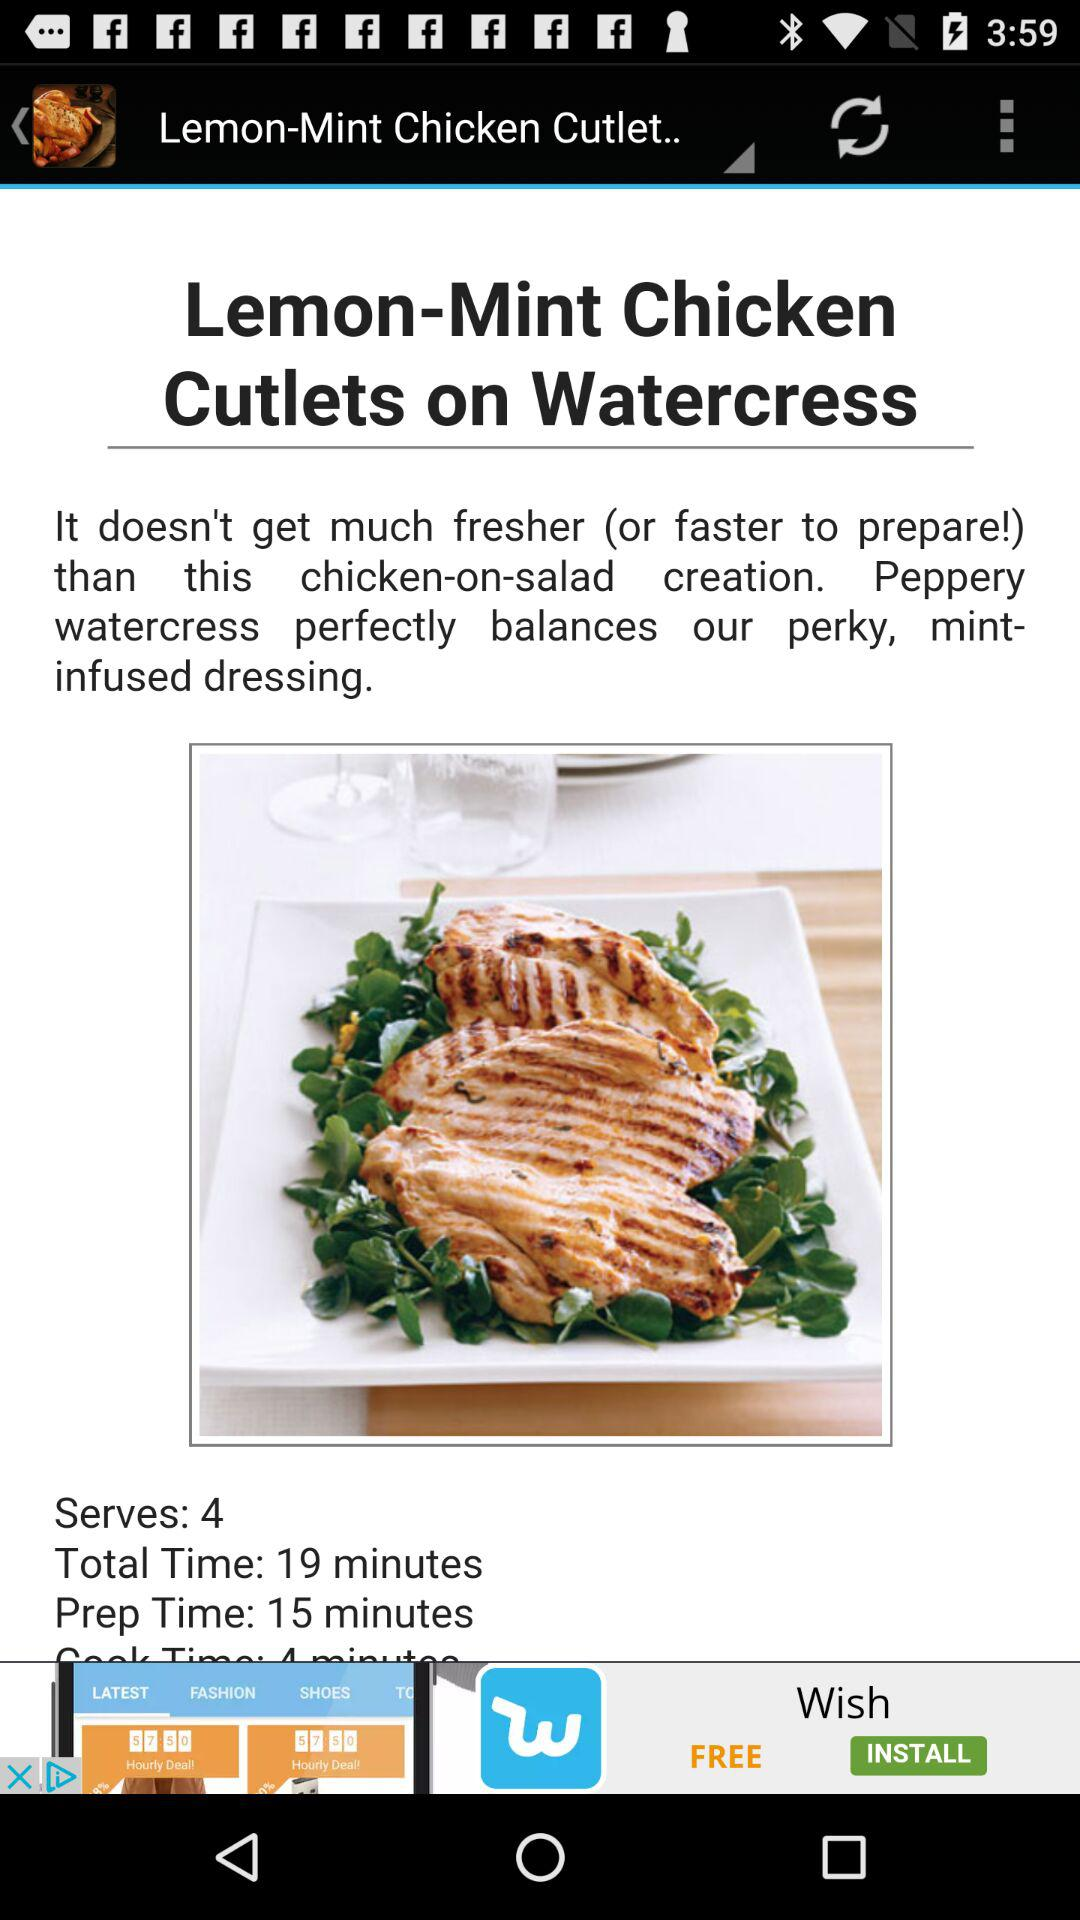What is the total time for the dish? The total time for the dish is 19 minutes. 